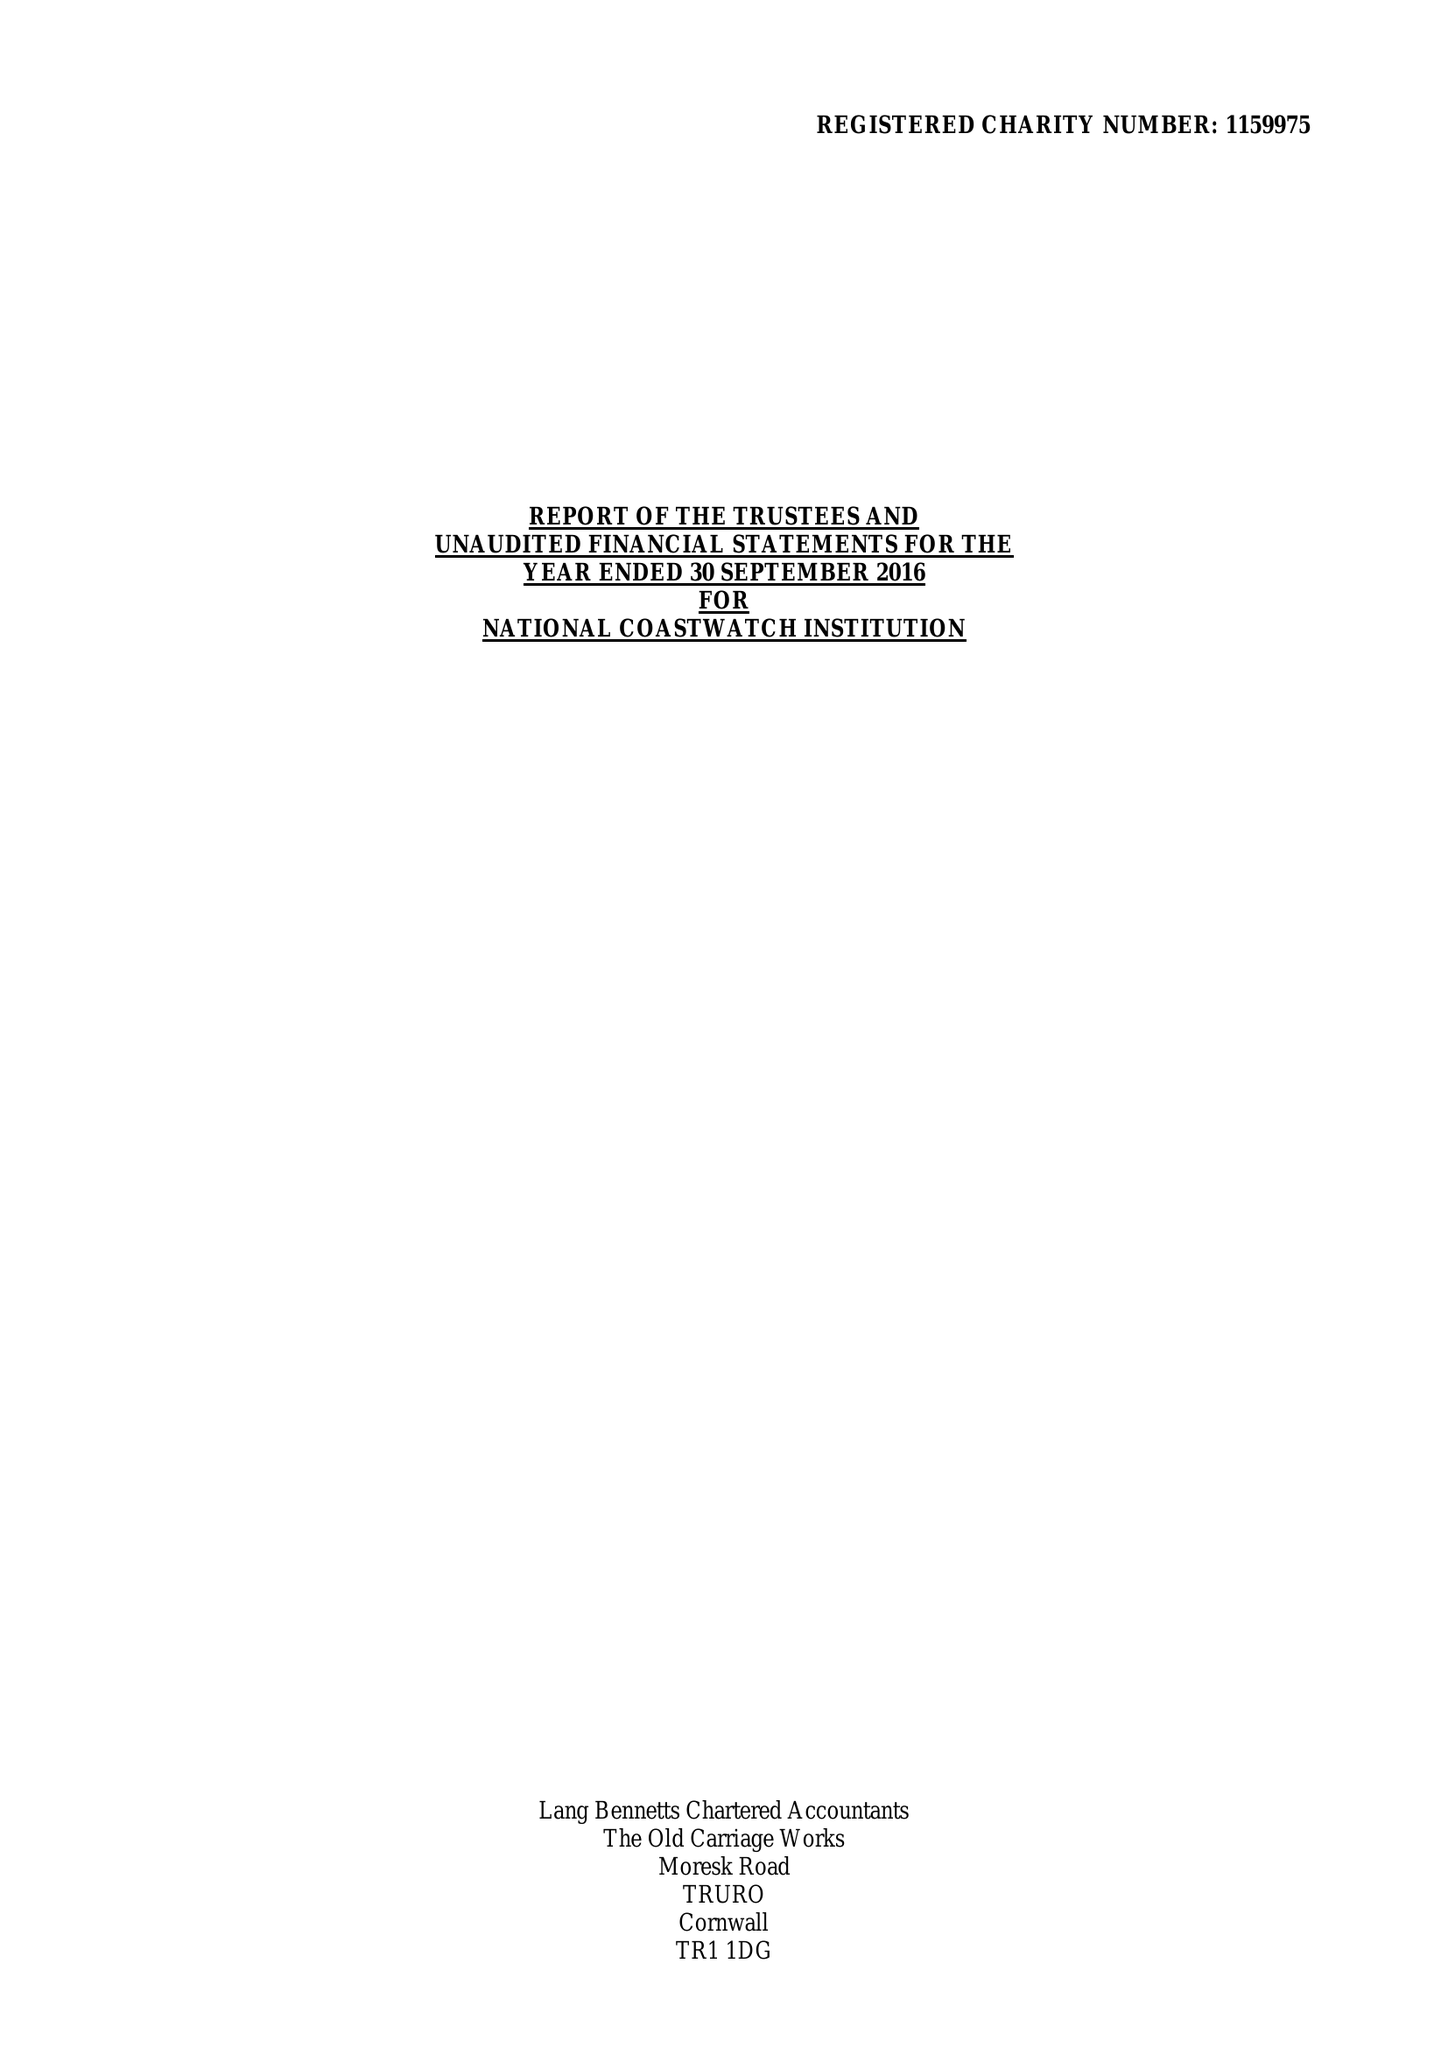What is the value for the charity_number?
Answer the question using a single word or phrase. 1159975 